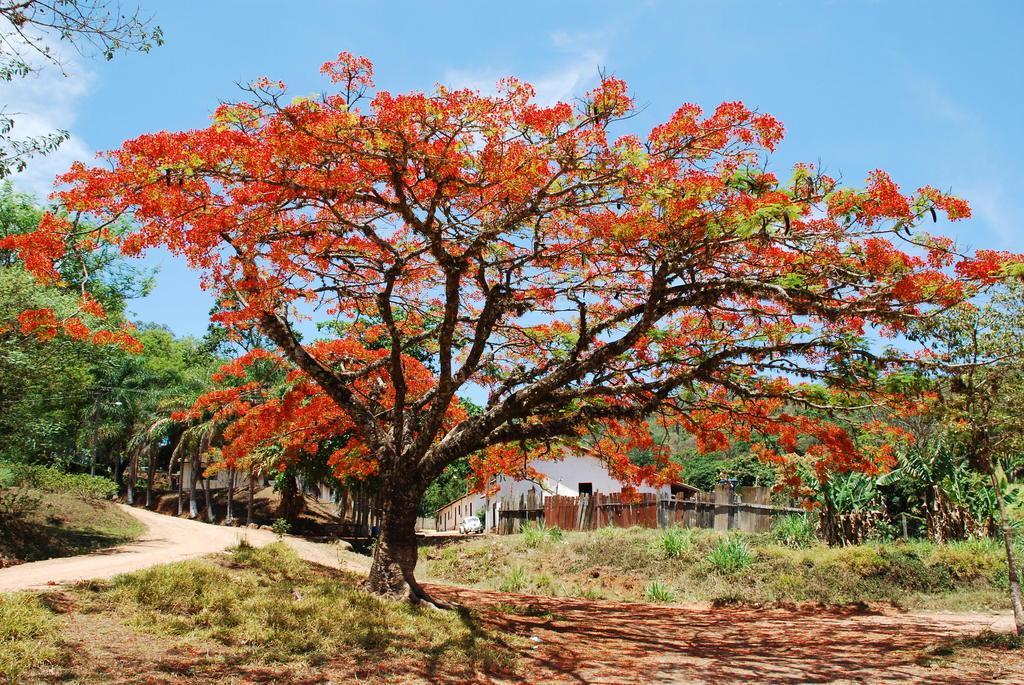Can you describe this image briefly? In this image I can see few flowers in red color, background I can see few trees in green color, the building in white color and the sky is in blue and white color. 